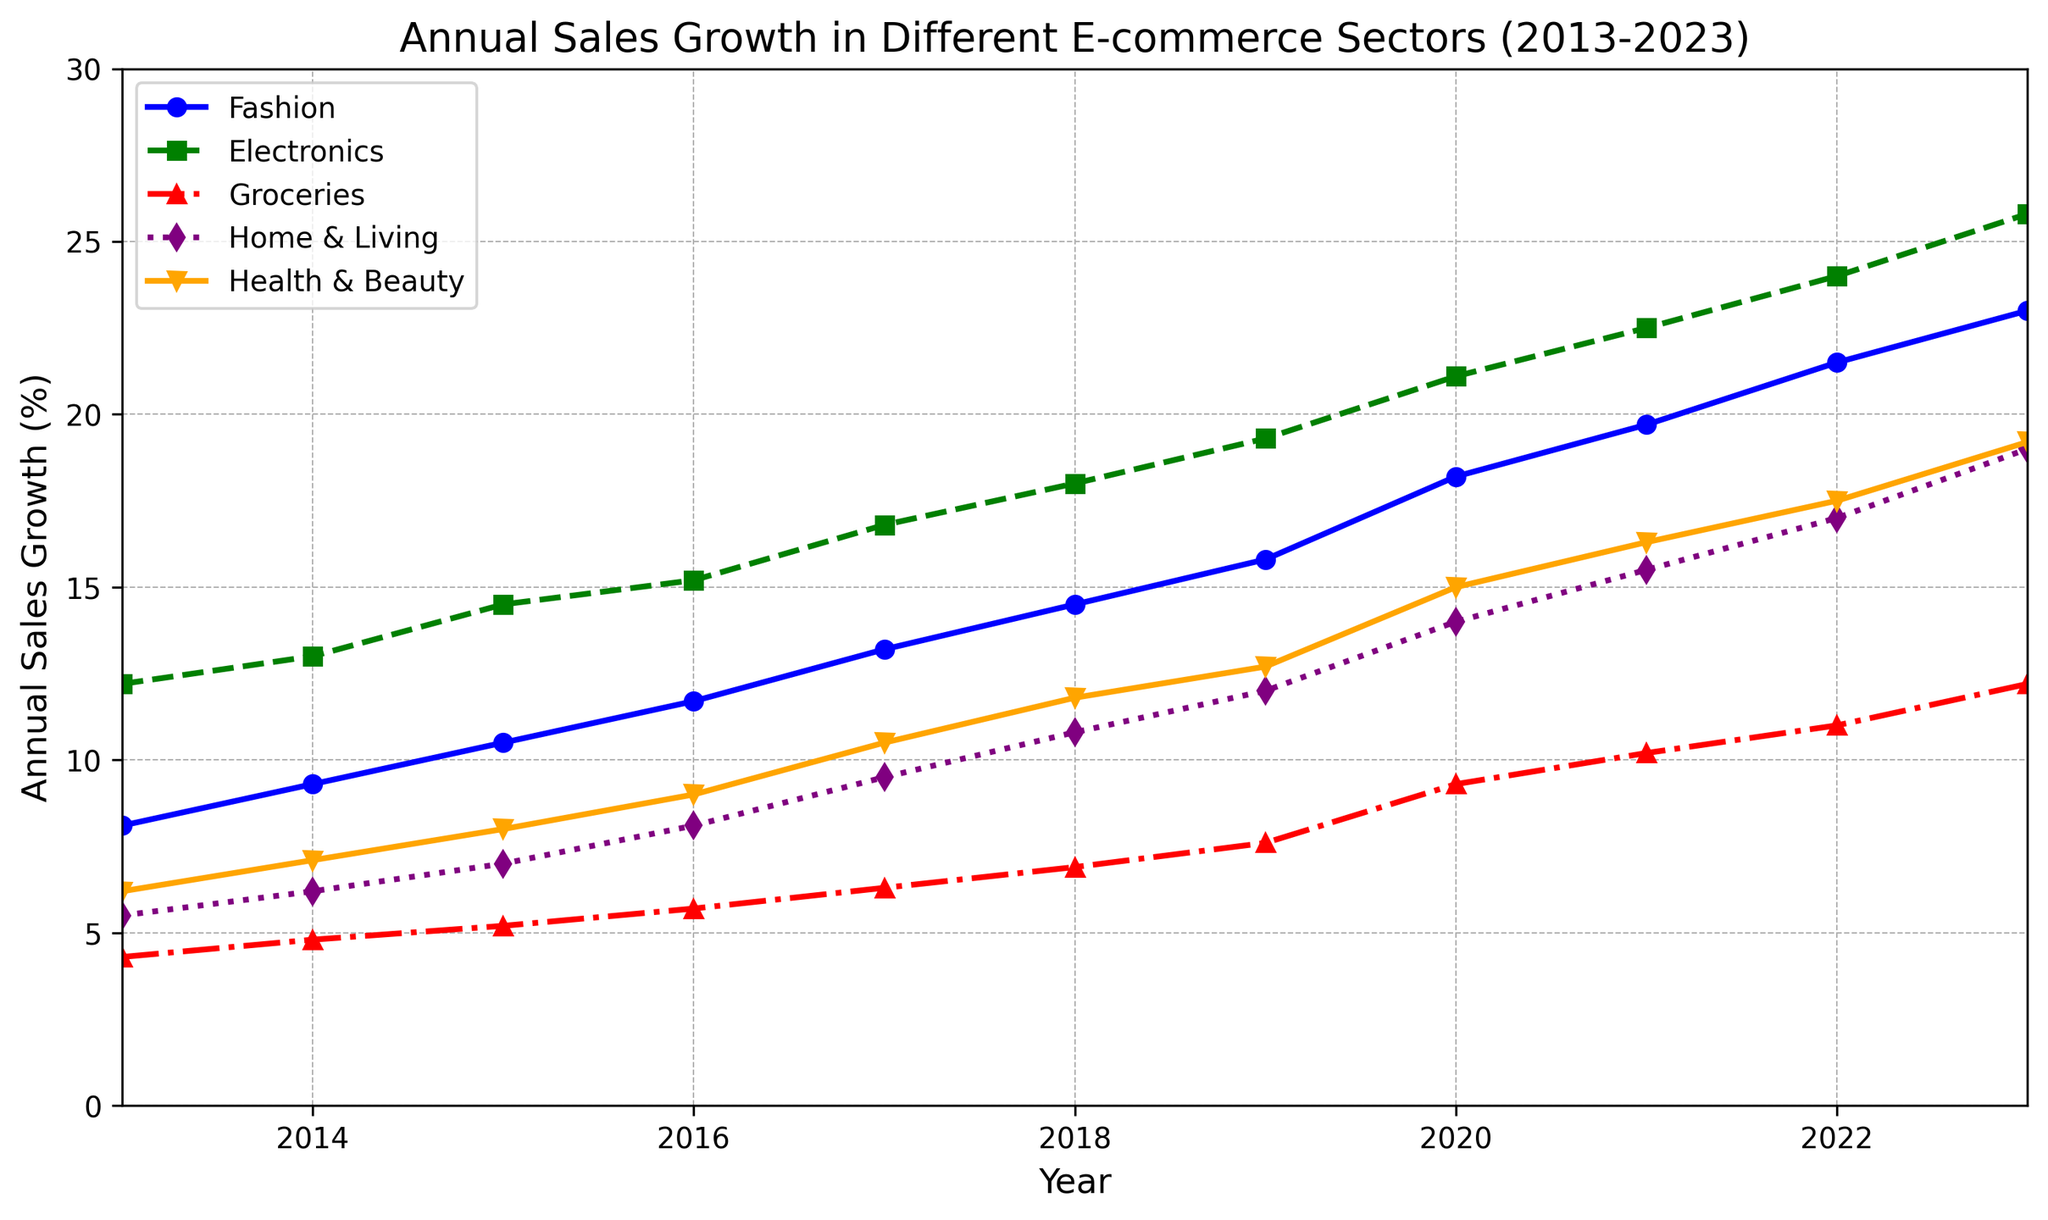Which e-commerce sector has the highest growth in 2023? Look at the endpoints (2023) of all the lines in the plot. The line with the highest endpoint represents the sector with the highest growth.
Answer: Electronics What is the average annual sales growth for the Fashion sector from 2013 to 2023? Sum the annual sales growth percentages for Fashion from 2013 to 2023 and divide by the number of years (11). Calculation: (8.1 + 9.3 + 10.5 + 11.7 + 13.2 + 14.5 + 15.8 + 18.2 + 19.7 + 21.5 + 23.0) / 11.
Answer: 14.9 How much greater is the annual sales growth for Health & Beauty in 2023 compared to 2013? Subtract the value for Health & Beauty in 2013 from the value in 2023. Calculation: 19.2 - 6.2.
Answer: 13.0 Which sector had the lowest annual sales growth in 2020? Find the point corresponding to 2020 on the x-axis and identify the sector with the lowest y-value.
Answer: Groceries By how much did the annual sales growth for Groceries increase from 2016 to 2021? Subtract the 2016 value from the 2021 value for Groceries. Calculation: 10.2 - 5.7.
Answer: 4.5 What is the average annual growth rate for Electronics between 2013 and 2016? Sum the annual sales growth percentages for Electronics from 2013 to 2016 and divide by the number of years (4). Calculation: (12.2 + 13.0 + 14.5 + 15.2) / 4.
Answer: 13.725 Which sector showed a declining trend in 2023? Check if any sector's line slopes downward in 2023. None of the sectors' lines slope downward in 2023.
Answer: None Compare the annual sales growth for Home & Living and Health & Beauty in 2015. Which one was higher? Compare the y-values for Home & Living and Health & Beauty in 2015.
Answer: Health & Beauty What is the difference in annual sales growth between Fashion and Groceries in 2019? Subtract the y-value of Groceries from the y-value of Fashion in 2019. Calculation: 15.8 - 7.6.
Answer: 8.2 Which sector had a consistent increase in annual sales growth without any decline throughout the period? Check all the lines to see which one continuously increases from 2013 to 2023 without any decline.
Answer: All 